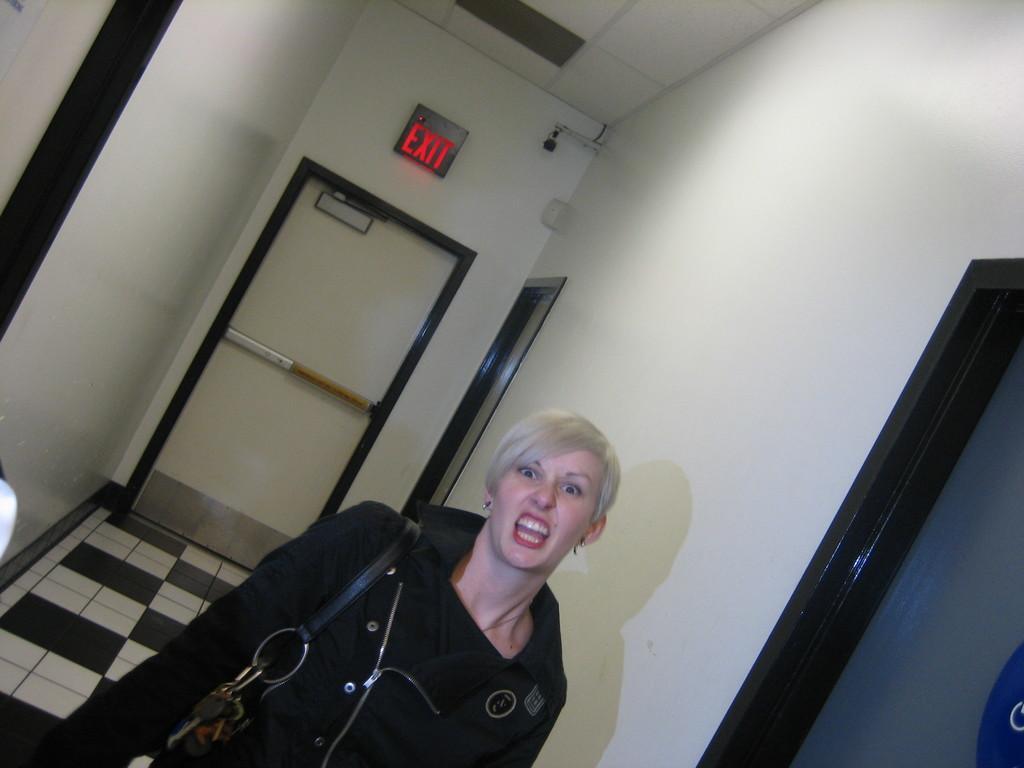Describe this image in one or two sentences. In this image I can see a person. In the background, I can see some text written on the wall. 